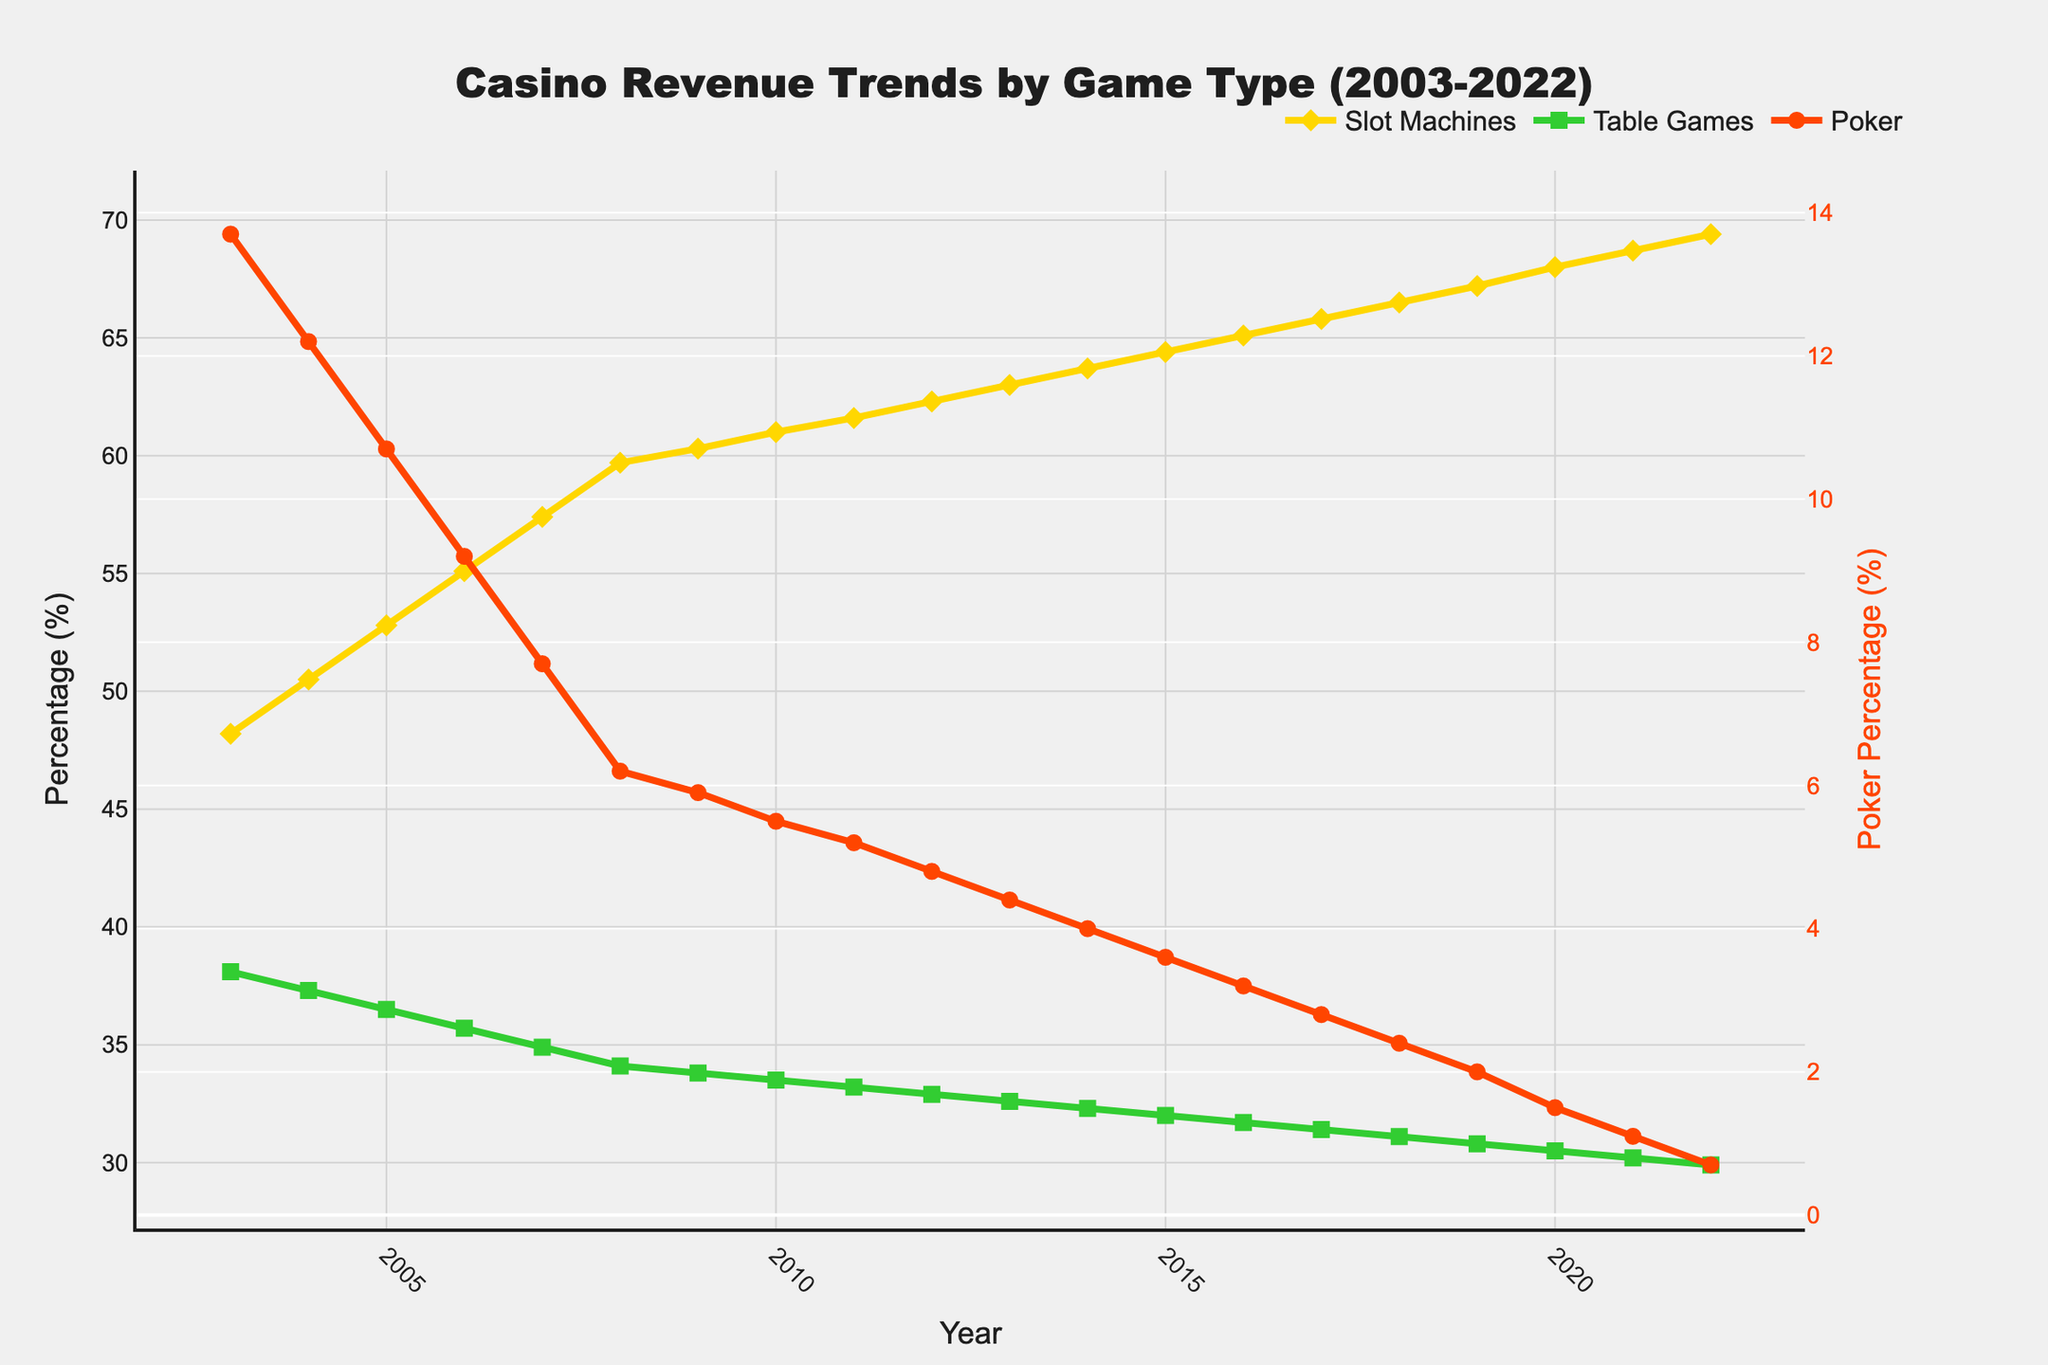Which game type consistently generated the highest percentage of revenue over the past 20 years? The "Slot Machines" line is always at the top across all years in the chart, indicating it consistently generated the highest percentage of revenue.
Answer: Slot Machines How did the revenue percentage for Table Games in 2022 compare to its value in 2003? The chart shows that Table Games' revenue percentage decreased from 38.1% in 2003 to 29.9% in 2022.
Answer: It decreased What was the change in Poker revenue percentage between 2003 and 2022? In 2003, Poker had a revenue percentage of 13.7%. By 2022, it dropped to 0.7%. The change is 13.7% - 0.7% = 13.0%.
Answer: 13.0% Between which years did the revenue percentage for Slot Machines increase the most? The steepest upward slope for Slot Machines is between 2003 and 2004, with an increase from 48.2% to 50.5%. The difference is 50.5% - 48.2% = 2.3%.
Answer: 2003-2004 How do the trends in revenue percentage for Slot Machines and Table Games from 2017 to 2022 compare? The percentage of revenue from Slot Machines shows a noticeable upward trend, rising from 65.8% in 2017 to 69.4% in 2022. In contrast, Table Games have a decreasing trend, dropping from 31.4% in 2017 to 29.9% in 2022.
Answer: Slot Machines increased, Table Games decreased What were the revenue percentages for Poker just before and after the 2008 financial crisis? The financial crisis peaked around 2008. In 2007, Poker had a revenue percentage of 7.7%, and in 2009, it was 5.9%.
Answer: 7.7% in 2007, 5.9% in 2009 Which game type showed the most dramatic percentage decrease over the entire period and by how much? Poker showed the largest percentage decrease from 13.7% in 2003 to 0.7% in 2022, a drop of 13.0% (13.7% - 0.7%).
Answer: Poker, 13.0% Are there any periods where the revenue trends for Slot Machines and Table Games stayed roughly parallel? From roughly 2010 to 2017, the revenue trends for Slot Machines and Table Games show parallel slopes with Slot Machines increasing slowly and Table Games decreasing slightly but consistently.
Answer: Yes, from 2010 to 2017 When did Poker revenue percentage drop below 5% for the first time? The chart shows that Poker revenue percentage first dropped below 5% in 2012, at the value of 4.8%.
Answer: 2012 